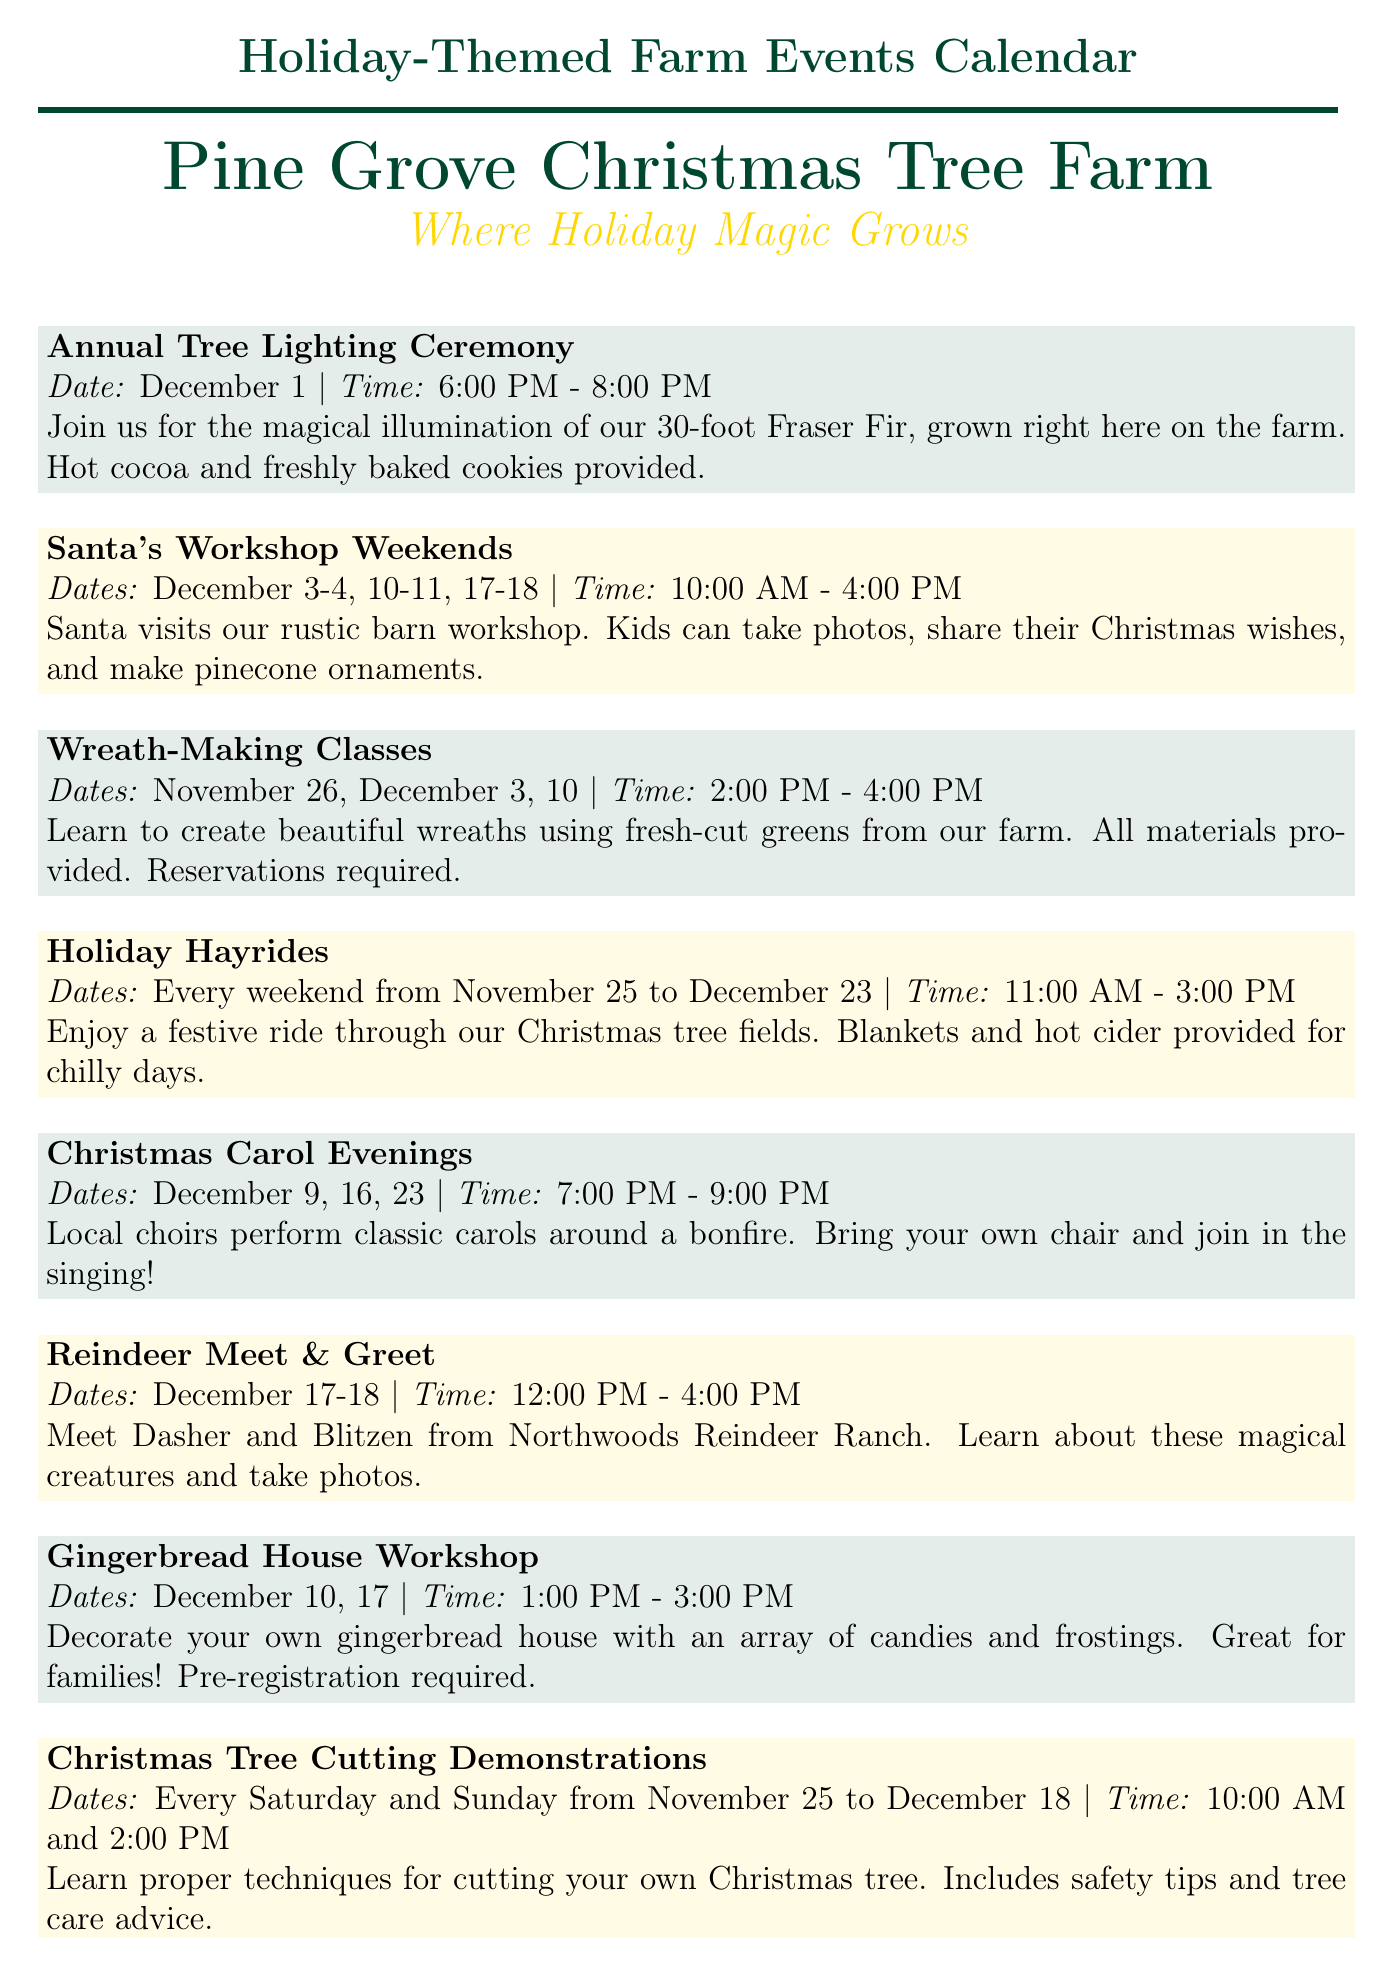What date is the Annual Tree Lighting Ceremony? The document specifies that the Annual Tree Lighting Ceremony occurs on December 1.
Answer: December 1 What time do Santa's Workshop Weekends start? According to the document, Santa's Workshop Weekends begin at 10:00 AM.
Answer: 10:00 AM How many weekends does Santa visit the workshop? The document lists three weekends for Santa's visits, indicating the frequency.
Answer: Three weekends What is provided at the Annual Tree Lighting Ceremony? The document mentions that hot cocoa and freshly baked cookies are provided at the ceremony.
Answer: Hot cocoa and freshly baked cookies When is the Holiday Market open? The document states the Holiday Market operates from 9:00 AM to 5:00 PM on specific weekends in December.
Answer: 9:00 AM - 5:00 PM How many days does the Reindeer Meet & Greet last? The document indicates the Reindeer Meet & Greet occurs over two days, December 17 and 18.
Answer: Two days What activities can children do at Santa's Workshop? The document details several activities, including taking photos and sharing Christmas wishes, available for kids during Santa's Workshop.
Answer: Take photos, share Christmas wishes, and make pinecone ornaments How often are the Christmas Tree Cutting Demonstrations held? The document notes that these demonstrations take place every Saturday and Sunday from November 25 to December 18.
Answer: Every Saturday and Sunday 